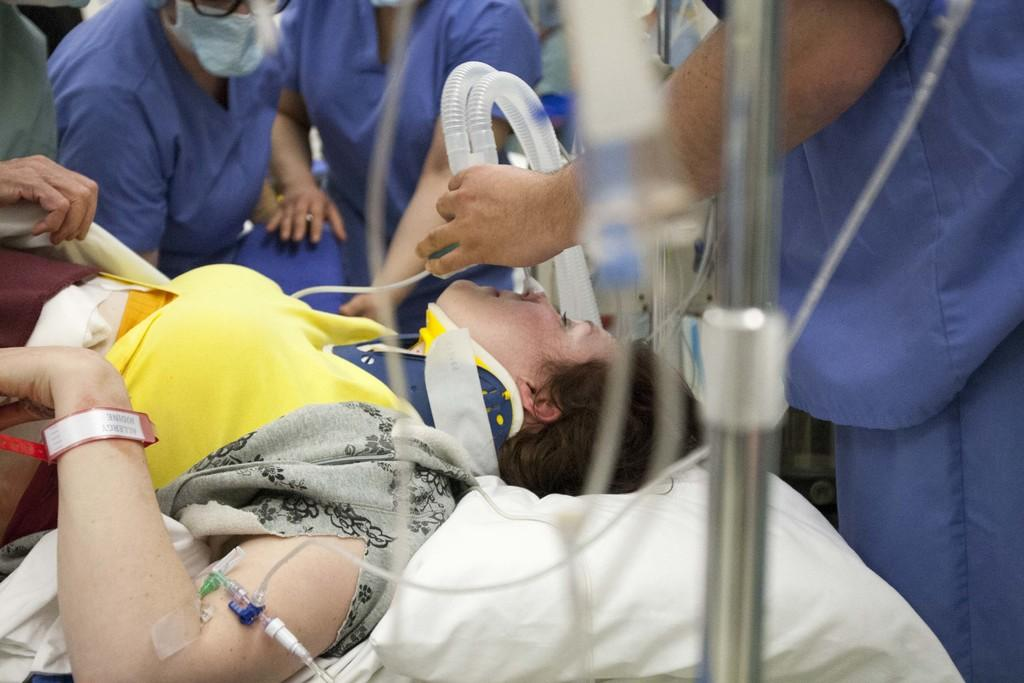What is the woman doing in the image? The woman is laying on the bed in the image. Who else is present in the image? There are doctors in the image. What are the doctors doing in the image? The doctors are giving treatment to the woman. What type of box is being used for dinner in the image? There is no box or dinner present in the image; it features a woman laying on the bed and doctors giving treatment. 